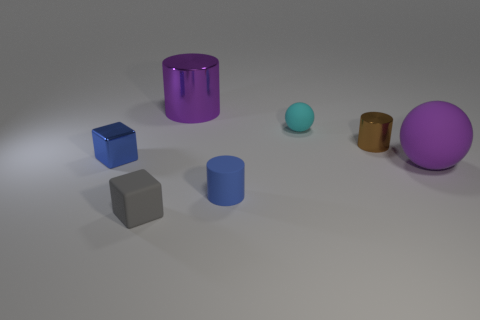Add 3 brown matte cubes. How many objects exist? 10 Subtract all balls. How many objects are left? 5 Add 6 blocks. How many blocks are left? 8 Add 5 big yellow metal spheres. How many big yellow metal spheres exist? 5 Subtract 0 cyan cylinders. How many objects are left? 7 Subtract all shiny things. Subtract all small rubber cylinders. How many objects are left? 3 